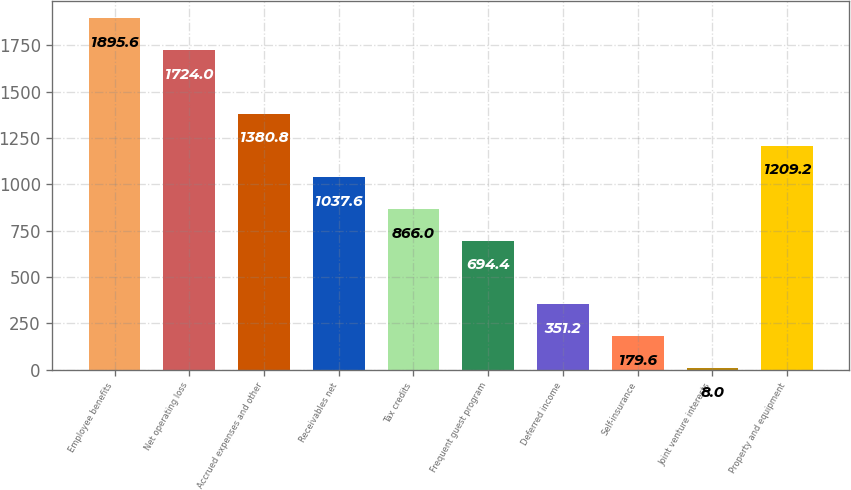<chart> <loc_0><loc_0><loc_500><loc_500><bar_chart><fcel>Employee benefits<fcel>Net operating loss<fcel>Accrued expenses and other<fcel>Receivables net<fcel>Tax credits<fcel>Frequent guest program<fcel>Deferred income<fcel>Self-insurance<fcel>Joint venture interests<fcel>Property and equipment<nl><fcel>1895.6<fcel>1724<fcel>1380.8<fcel>1037.6<fcel>866<fcel>694.4<fcel>351.2<fcel>179.6<fcel>8<fcel>1209.2<nl></chart> 